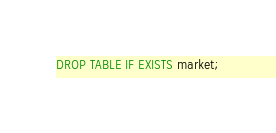Convert code to text. <code><loc_0><loc_0><loc_500><loc_500><_SQL_>DROP TABLE IF EXISTS market;</code> 